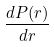Convert formula to latex. <formula><loc_0><loc_0><loc_500><loc_500>\frac { d P ( r ) } { d r }</formula> 